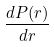Convert formula to latex. <formula><loc_0><loc_0><loc_500><loc_500>\frac { d P ( r ) } { d r }</formula> 